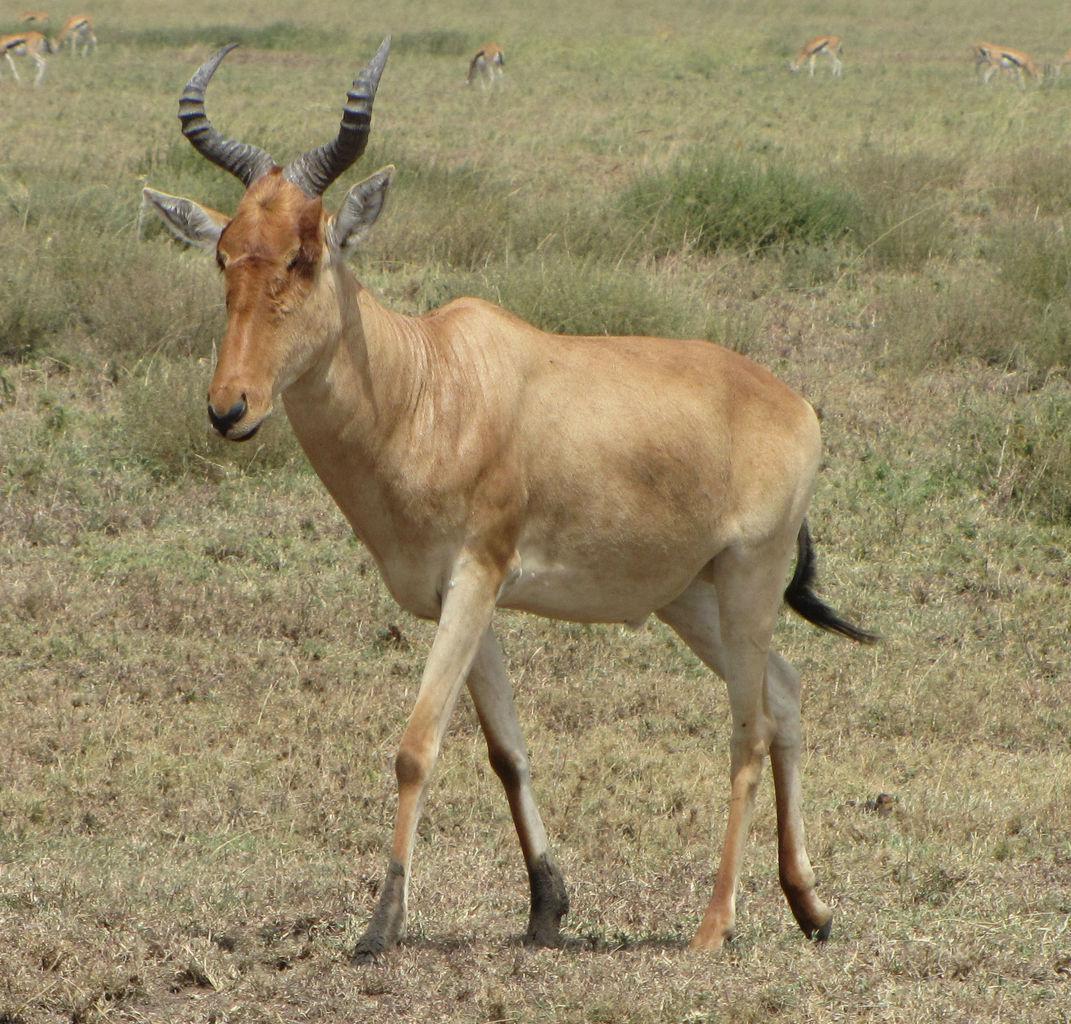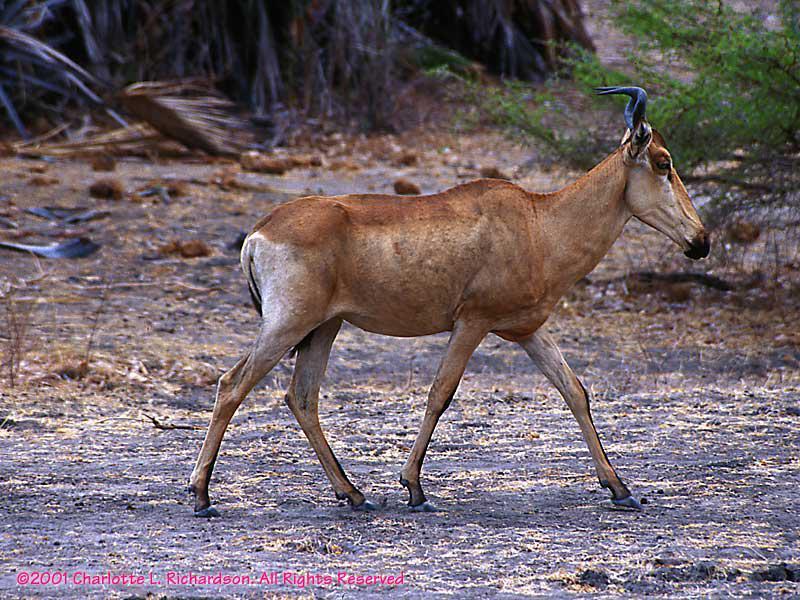The first image is the image on the left, the second image is the image on the right. Considering the images on both sides, is "There are more than 8 animals total." valid? Answer yes or no. No. The first image is the image on the left, the second image is the image on the right. Analyze the images presented: Is the assertion "There is a single brown dear with black antlers facing or walking right." valid? Answer yes or no. Yes. 